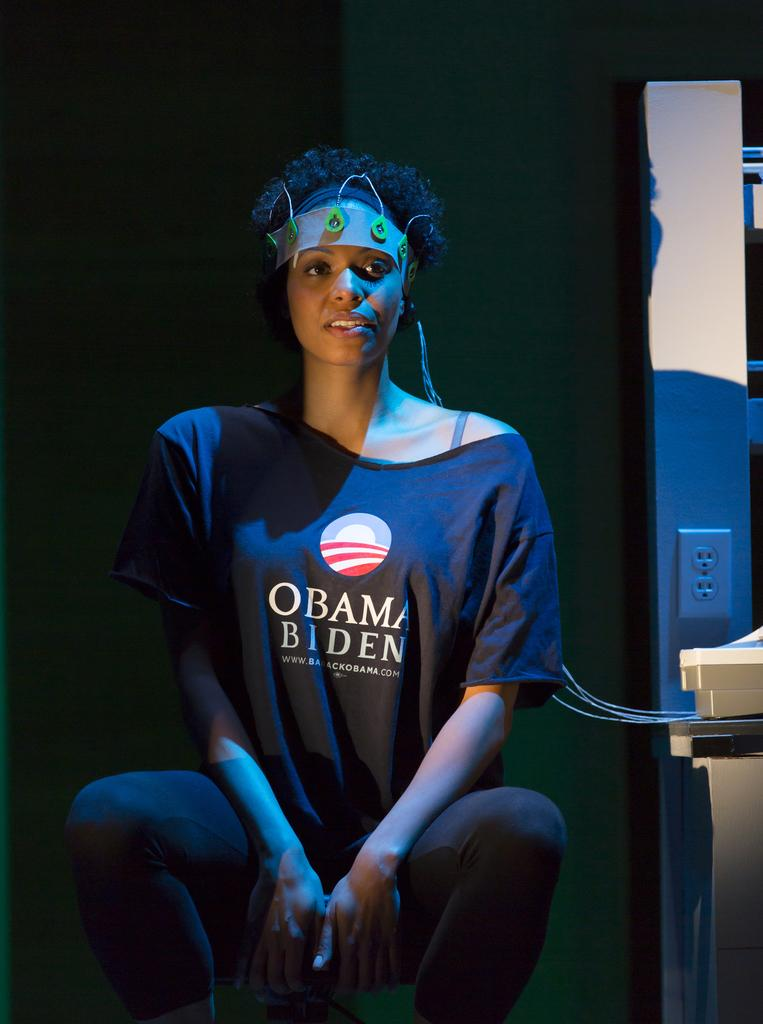Who is present in the image? There is a woman in the image. What is the woman's facial expression? The woman is smiling. What can be seen beside the woman? There are objects beside the woman. What is visible in the background of the image? There is a wall in the background of the image. What type of support can be seen holding up the turkey in the image? There is no turkey present in the image, so there is no support for it. 